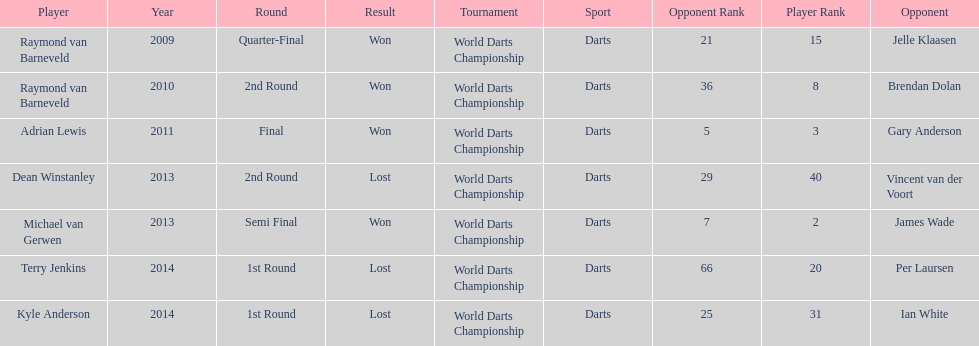Could you help me parse every detail presented in this table? {'header': ['Player', 'Year', 'Round', 'Result', 'Tournament', 'Sport', 'Opponent Rank', 'Player Rank', 'Opponent'], 'rows': [['Raymond van Barneveld', '2009', 'Quarter-Final', 'Won', 'World Darts Championship', 'Darts', '21', '15', 'Jelle Klaasen'], ['Raymond van Barneveld', '2010', '2nd Round', 'Won', 'World Darts Championship', 'Darts', '36', '8', 'Brendan Dolan'], ['Adrian Lewis', '2011', 'Final', 'Won', 'World Darts Championship', 'Darts', '5', '3', 'Gary Anderson'], ['Dean Winstanley', '2013', '2nd Round', 'Lost', 'World Darts Championship', 'Darts', '29', '40', 'Vincent van der Voort'], ['Michael van Gerwen', '2013', 'Semi Final', 'Won', 'World Darts Championship', 'Darts', '7', '2', 'James Wade'], ['Terry Jenkins', '2014', '1st Round', 'Lost', 'World Darts Championship', 'Darts', '66', '20', 'Per Laursen'], ['Kyle Anderson', '2014', '1st Round', 'Lost', 'World Darts Championship', 'Darts', '25', '31', 'Ian White']]} Did terry jenkins or per laursen win in 2014? Per Laursen. 